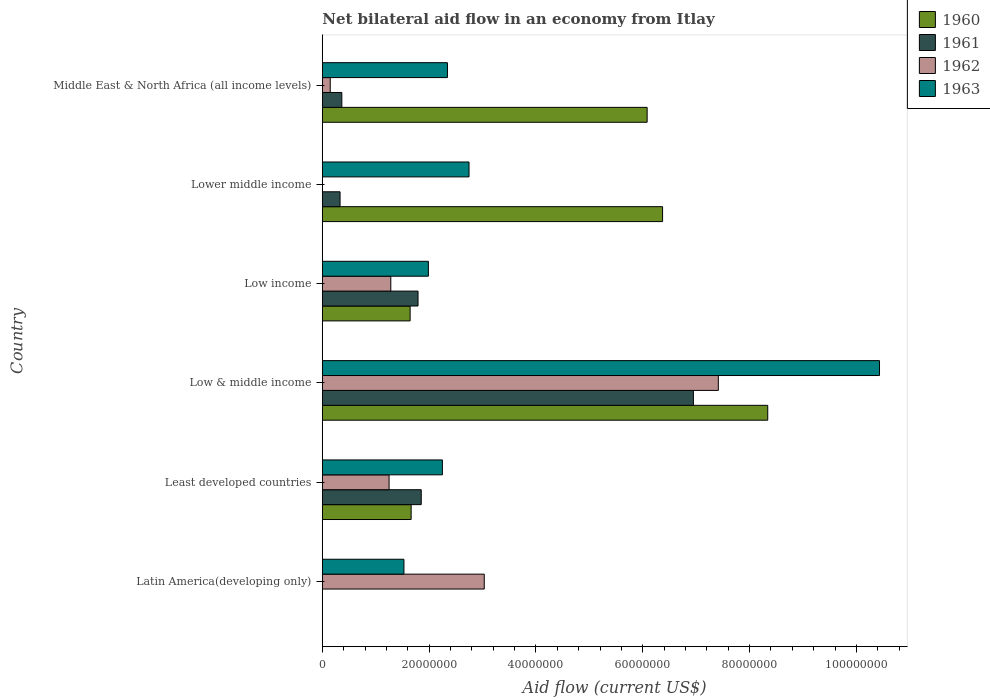How many bars are there on the 2nd tick from the top?
Keep it short and to the point. 3. How many bars are there on the 1st tick from the bottom?
Give a very brief answer. 2. What is the label of the 3rd group of bars from the top?
Offer a very short reply. Low income. What is the net bilateral aid flow in 1963 in Lower middle income?
Provide a succinct answer. 2.75e+07. Across all countries, what is the maximum net bilateral aid flow in 1963?
Provide a succinct answer. 1.04e+08. Across all countries, what is the minimum net bilateral aid flow in 1960?
Offer a terse response. 0. What is the total net bilateral aid flow in 1963 in the graph?
Make the answer very short. 2.13e+08. What is the difference between the net bilateral aid flow in 1963 in Latin America(developing only) and that in Low & middle income?
Give a very brief answer. -8.90e+07. What is the average net bilateral aid flow in 1961 per country?
Keep it short and to the point. 1.88e+07. What is the difference between the net bilateral aid flow in 1962 and net bilateral aid flow in 1961 in Least developed countries?
Offer a very short reply. -6.02e+06. In how many countries, is the net bilateral aid flow in 1960 greater than 104000000 US$?
Offer a terse response. 0. What is the ratio of the net bilateral aid flow in 1961 in Low income to that in Lower middle income?
Make the answer very short. 5.4. Is the net bilateral aid flow in 1963 in Low & middle income less than that in Middle East & North Africa (all income levels)?
Offer a very short reply. No. What is the difference between the highest and the second highest net bilateral aid flow in 1960?
Offer a very short reply. 1.97e+07. What is the difference between the highest and the lowest net bilateral aid flow in 1962?
Ensure brevity in your answer.  7.42e+07. In how many countries, is the net bilateral aid flow in 1962 greater than the average net bilateral aid flow in 1962 taken over all countries?
Your answer should be very brief. 2. Are all the bars in the graph horizontal?
Ensure brevity in your answer.  Yes. Are the values on the major ticks of X-axis written in scientific E-notation?
Provide a short and direct response. No. Does the graph contain any zero values?
Offer a terse response. Yes. How many legend labels are there?
Your answer should be very brief. 4. How are the legend labels stacked?
Give a very brief answer. Vertical. What is the title of the graph?
Ensure brevity in your answer.  Net bilateral aid flow in an economy from Itlay. What is the label or title of the X-axis?
Offer a terse response. Aid flow (current US$). What is the label or title of the Y-axis?
Offer a very short reply. Country. What is the Aid flow (current US$) of 1960 in Latin America(developing only)?
Offer a terse response. 0. What is the Aid flow (current US$) in 1962 in Latin America(developing only)?
Your answer should be compact. 3.03e+07. What is the Aid flow (current US$) in 1963 in Latin America(developing only)?
Your answer should be very brief. 1.53e+07. What is the Aid flow (current US$) in 1960 in Least developed countries?
Ensure brevity in your answer.  1.66e+07. What is the Aid flow (current US$) of 1961 in Least developed countries?
Make the answer very short. 1.85e+07. What is the Aid flow (current US$) in 1962 in Least developed countries?
Your answer should be compact. 1.25e+07. What is the Aid flow (current US$) in 1963 in Least developed countries?
Provide a short and direct response. 2.25e+07. What is the Aid flow (current US$) in 1960 in Low & middle income?
Keep it short and to the point. 8.34e+07. What is the Aid flow (current US$) of 1961 in Low & middle income?
Provide a short and direct response. 6.95e+07. What is the Aid flow (current US$) of 1962 in Low & middle income?
Offer a very short reply. 7.42e+07. What is the Aid flow (current US$) of 1963 in Low & middle income?
Your answer should be compact. 1.04e+08. What is the Aid flow (current US$) in 1960 in Low income?
Ensure brevity in your answer.  1.64e+07. What is the Aid flow (current US$) in 1961 in Low income?
Provide a short and direct response. 1.79e+07. What is the Aid flow (current US$) in 1962 in Low income?
Make the answer very short. 1.28e+07. What is the Aid flow (current US$) in 1963 in Low income?
Offer a very short reply. 1.99e+07. What is the Aid flow (current US$) in 1960 in Lower middle income?
Provide a succinct answer. 6.37e+07. What is the Aid flow (current US$) in 1961 in Lower middle income?
Offer a very short reply. 3.32e+06. What is the Aid flow (current US$) in 1963 in Lower middle income?
Offer a very short reply. 2.75e+07. What is the Aid flow (current US$) in 1960 in Middle East & North Africa (all income levels)?
Offer a very short reply. 6.08e+07. What is the Aid flow (current US$) of 1961 in Middle East & North Africa (all income levels)?
Make the answer very short. 3.65e+06. What is the Aid flow (current US$) in 1962 in Middle East & North Africa (all income levels)?
Give a very brief answer. 1.48e+06. What is the Aid flow (current US$) in 1963 in Middle East & North Africa (all income levels)?
Your answer should be very brief. 2.34e+07. Across all countries, what is the maximum Aid flow (current US$) of 1960?
Provide a short and direct response. 8.34e+07. Across all countries, what is the maximum Aid flow (current US$) of 1961?
Offer a terse response. 6.95e+07. Across all countries, what is the maximum Aid flow (current US$) in 1962?
Offer a very short reply. 7.42e+07. Across all countries, what is the maximum Aid flow (current US$) of 1963?
Make the answer very short. 1.04e+08. Across all countries, what is the minimum Aid flow (current US$) in 1960?
Provide a short and direct response. 0. Across all countries, what is the minimum Aid flow (current US$) of 1961?
Provide a succinct answer. 0. Across all countries, what is the minimum Aid flow (current US$) in 1962?
Offer a terse response. 0. Across all countries, what is the minimum Aid flow (current US$) of 1963?
Offer a terse response. 1.53e+07. What is the total Aid flow (current US$) in 1960 in the graph?
Your answer should be compact. 2.41e+08. What is the total Aid flow (current US$) in 1961 in the graph?
Offer a terse response. 1.13e+08. What is the total Aid flow (current US$) of 1962 in the graph?
Your answer should be very brief. 1.31e+08. What is the total Aid flow (current US$) in 1963 in the graph?
Your response must be concise. 2.13e+08. What is the difference between the Aid flow (current US$) in 1962 in Latin America(developing only) and that in Least developed countries?
Keep it short and to the point. 1.78e+07. What is the difference between the Aid flow (current US$) in 1963 in Latin America(developing only) and that in Least developed countries?
Offer a very short reply. -7.20e+06. What is the difference between the Aid flow (current US$) in 1962 in Latin America(developing only) and that in Low & middle income?
Make the answer very short. -4.38e+07. What is the difference between the Aid flow (current US$) in 1963 in Latin America(developing only) and that in Low & middle income?
Give a very brief answer. -8.90e+07. What is the difference between the Aid flow (current US$) in 1962 in Latin America(developing only) and that in Low income?
Ensure brevity in your answer.  1.75e+07. What is the difference between the Aid flow (current US$) of 1963 in Latin America(developing only) and that in Low income?
Ensure brevity in your answer.  -4.58e+06. What is the difference between the Aid flow (current US$) in 1963 in Latin America(developing only) and that in Lower middle income?
Your response must be concise. -1.22e+07. What is the difference between the Aid flow (current US$) of 1962 in Latin America(developing only) and that in Middle East & North Africa (all income levels)?
Your answer should be compact. 2.88e+07. What is the difference between the Aid flow (current US$) of 1963 in Latin America(developing only) and that in Middle East & North Africa (all income levels)?
Provide a succinct answer. -8.15e+06. What is the difference between the Aid flow (current US$) of 1960 in Least developed countries and that in Low & middle income?
Your answer should be very brief. -6.68e+07. What is the difference between the Aid flow (current US$) in 1961 in Least developed countries and that in Low & middle income?
Provide a short and direct response. -5.10e+07. What is the difference between the Aid flow (current US$) of 1962 in Least developed countries and that in Low & middle income?
Make the answer very short. -6.16e+07. What is the difference between the Aid flow (current US$) of 1963 in Least developed countries and that in Low & middle income?
Keep it short and to the point. -8.18e+07. What is the difference between the Aid flow (current US$) in 1960 in Least developed countries and that in Low income?
Your answer should be very brief. 1.90e+05. What is the difference between the Aid flow (current US$) in 1961 in Least developed countries and that in Low income?
Give a very brief answer. 6.00e+05. What is the difference between the Aid flow (current US$) of 1962 in Least developed countries and that in Low income?
Offer a very short reply. -3.20e+05. What is the difference between the Aid flow (current US$) of 1963 in Least developed countries and that in Low income?
Ensure brevity in your answer.  2.62e+06. What is the difference between the Aid flow (current US$) in 1960 in Least developed countries and that in Lower middle income?
Your response must be concise. -4.71e+07. What is the difference between the Aid flow (current US$) of 1961 in Least developed countries and that in Lower middle income?
Give a very brief answer. 1.52e+07. What is the difference between the Aid flow (current US$) of 1963 in Least developed countries and that in Lower middle income?
Offer a very short reply. -4.99e+06. What is the difference between the Aid flow (current US$) in 1960 in Least developed countries and that in Middle East & North Africa (all income levels)?
Your answer should be very brief. -4.42e+07. What is the difference between the Aid flow (current US$) of 1961 in Least developed countries and that in Middle East & North Africa (all income levels)?
Offer a very short reply. 1.49e+07. What is the difference between the Aid flow (current US$) of 1962 in Least developed countries and that in Middle East & North Africa (all income levels)?
Your answer should be very brief. 1.10e+07. What is the difference between the Aid flow (current US$) of 1963 in Least developed countries and that in Middle East & North Africa (all income levels)?
Ensure brevity in your answer.  -9.50e+05. What is the difference between the Aid flow (current US$) of 1960 in Low & middle income and that in Low income?
Your answer should be very brief. 6.70e+07. What is the difference between the Aid flow (current US$) of 1961 in Low & middle income and that in Low income?
Offer a terse response. 5.16e+07. What is the difference between the Aid flow (current US$) of 1962 in Low & middle income and that in Low income?
Give a very brief answer. 6.13e+07. What is the difference between the Aid flow (current US$) in 1963 in Low & middle income and that in Low income?
Give a very brief answer. 8.45e+07. What is the difference between the Aid flow (current US$) of 1960 in Low & middle income and that in Lower middle income?
Provide a short and direct response. 1.97e+07. What is the difference between the Aid flow (current US$) of 1961 in Low & middle income and that in Lower middle income?
Give a very brief answer. 6.62e+07. What is the difference between the Aid flow (current US$) of 1963 in Low & middle income and that in Lower middle income?
Provide a short and direct response. 7.69e+07. What is the difference between the Aid flow (current US$) of 1960 in Low & middle income and that in Middle East & North Africa (all income levels)?
Your response must be concise. 2.26e+07. What is the difference between the Aid flow (current US$) of 1961 in Low & middle income and that in Middle East & North Africa (all income levels)?
Your answer should be very brief. 6.58e+07. What is the difference between the Aid flow (current US$) of 1962 in Low & middle income and that in Middle East & North Africa (all income levels)?
Offer a very short reply. 7.27e+07. What is the difference between the Aid flow (current US$) of 1963 in Low & middle income and that in Middle East & North Africa (all income levels)?
Provide a succinct answer. 8.09e+07. What is the difference between the Aid flow (current US$) in 1960 in Low income and that in Lower middle income?
Offer a very short reply. -4.73e+07. What is the difference between the Aid flow (current US$) in 1961 in Low income and that in Lower middle income?
Make the answer very short. 1.46e+07. What is the difference between the Aid flow (current US$) in 1963 in Low income and that in Lower middle income?
Give a very brief answer. -7.61e+06. What is the difference between the Aid flow (current US$) in 1960 in Low income and that in Middle East & North Africa (all income levels)?
Make the answer very short. -4.44e+07. What is the difference between the Aid flow (current US$) of 1961 in Low income and that in Middle East & North Africa (all income levels)?
Provide a succinct answer. 1.43e+07. What is the difference between the Aid flow (current US$) in 1962 in Low income and that in Middle East & North Africa (all income levels)?
Keep it short and to the point. 1.13e+07. What is the difference between the Aid flow (current US$) in 1963 in Low income and that in Middle East & North Africa (all income levels)?
Give a very brief answer. -3.57e+06. What is the difference between the Aid flow (current US$) in 1960 in Lower middle income and that in Middle East & North Africa (all income levels)?
Keep it short and to the point. 2.89e+06. What is the difference between the Aid flow (current US$) of 1961 in Lower middle income and that in Middle East & North Africa (all income levels)?
Provide a short and direct response. -3.30e+05. What is the difference between the Aid flow (current US$) of 1963 in Lower middle income and that in Middle East & North Africa (all income levels)?
Ensure brevity in your answer.  4.04e+06. What is the difference between the Aid flow (current US$) in 1962 in Latin America(developing only) and the Aid flow (current US$) in 1963 in Least developed countries?
Your response must be concise. 7.84e+06. What is the difference between the Aid flow (current US$) in 1962 in Latin America(developing only) and the Aid flow (current US$) in 1963 in Low & middle income?
Provide a succinct answer. -7.40e+07. What is the difference between the Aid flow (current US$) of 1962 in Latin America(developing only) and the Aid flow (current US$) of 1963 in Low income?
Give a very brief answer. 1.05e+07. What is the difference between the Aid flow (current US$) of 1962 in Latin America(developing only) and the Aid flow (current US$) of 1963 in Lower middle income?
Ensure brevity in your answer.  2.85e+06. What is the difference between the Aid flow (current US$) in 1962 in Latin America(developing only) and the Aid flow (current US$) in 1963 in Middle East & North Africa (all income levels)?
Your answer should be compact. 6.89e+06. What is the difference between the Aid flow (current US$) in 1960 in Least developed countries and the Aid flow (current US$) in 1961 in Low & middle income?
Your response must be concise. -5.28e+07. What is the difference between the Aid flow (current US$) in 1960 in Least developed countries and the Aid flow (current US$) in 1962 in Low & middle income?
Provide a succinct answer. -5.75e+07. What is the difference between the Aid flow (current US$) of 1960 in Least developed countries and the Aid flow (current US$) of 1963 in Low & middle income?
Your response must be concise. -8.77e+07. What is the difference between the Aid flow (current US$) in 1961 in Least developed countries and the Aid flow (current US$) in 1962 in Low & middle income?
Give a very brief answer. -5.56e+07. What is the difference between the Aid flow (current US$) in 1961 in Least developed countries and the Aid flow (current US$) in 1963 in Low & middle income?
Provide a succinct answer. -8.58e+07. What is the difference between the Aid flow (current US$) in 1962 in Least developed countries and the Aid flow (current US$) in 1963 in Low & middle income?
Your answer should be very brief. -9.18e+07. What is the difference between the Aid flow (current US$) of 1960 in Least developed countries and the Aid flow (current US$) of 1961 in Low income?
Keep it short and to the point. -1.29e+06. What is the difference between the Aid flow (current US$) of 1960 in Least developed countries and the Aid flow (current US$) of 1962 in Low income?
Offer a terse response. 3.81e+06. What is the difference between the Aid flow (current US$) in 1960 in Least developed countries and the Aid flow (current US$) in 1963 in Low income?
Provide a short and direct response. -3.23e+06. What is the difference between the Aid flow (current US$) in 1961 in Least developed countries and the Aid flow (current US$) in 1962 in Low income?
Ensure brevity in your answer.  5.70e+06. What is the difference between the Aid flow (current US$) in 1961 in Least developed countries and the Aid flow (current US$) in 1963 in Low income?
Keep it short and to the point. -1.34e+06. What is the difference between the Aid flow (current US$) of 1962 in Least developed countries and the Aid flow (current US$) of 1963 in Low income?
Keep it short and to the point. -7.36e+06. What is the difference between the Aid flow (current US$) in 1960 in Least developed countries and the Aid flow (current US$) in 1961 in Lower middle income?
Offer a very short reply. 1.33e+07. What is the difference between the Aid flow (current US$) in 1960 in Least developed countries and the Aid flow (current US$) in 1963 in Lower middle income?
Provide a short and direct response. -1.08e+07. What is the difference between the Aid flow (current US$) in 1961 in Least developed countries and the Aid flow (current US$) in 1963 in Lower middle income?
Offer a very short reply. -8.95e+06. What is the difference between the Aid flow (current US$) of 1962 in Least developed countries and the Aid flow (current US$) of 1963 in Lower middle income?
Your answer should be very brief. -1.50e+07. What is the difference between the Aid flow (current US$) in 1960 in Least developed countries and the Aid flow (current US$) in 1961 in Middle East & North Africa (all income levels)?
Make the answer very short. 1.30e+07. What is the difference between the Aid flow (current US$) in 1960 in Least developed countries and the Aid flow (current US$) in 1962 in Middle East & North Africa (all income levels)?
Offer a terse response. 1.52e+07. What is the difference between the Aid flow (current US$) in 1960 in Least developed countries and the Aid flow (current US$) in 1963 in Middle East & North Africa (all income levels)?
Your answer should be very brief. -6.80e+06. What is the difference between the Aid flow (current US$) of 1961 in Least developed countries and the Aid flow (current US$) of 1962 in Middle East & North Africa (all income levels)?
Your response must be concise. 1.70e+07. What is the difference between the Aid flow (current US$) of 1961 in Least developed countries and the Aid flow (current US$) of 1963 in Middle East & North Africa (all income levels)?
Provide a short and direct response. -4.91e+06. What is the difference between the Aid flow (current US$) in 1962 in Least developed countries and the Aid flow (current US$) in 1963 in Middle East & North Africa (all income levels)?
Your answer should be compact. -1.09e+07. What is the difference between the Aid flow (current US$) in 1960 in Low & middle income and the Aid flow (current US$) in 1961 in Low income?
Provide a succinct answer. 6.55e+07. What is the difference between the Aid flow (current US$) of 1960 in Low & middle income and the Aid flow (current US$) of 1962 in Low income?
Your answer should be compact. 7.06e+07. What is the difference between the Aid flow (current US$) of 1960 in Low & middle income and the Aid flow (current US$) of 1963 in Low income?
Give a very brief answer. 6.35e+07. What is the difference between the Aid flow (current US$) of 1961 in Low & middle income and the Aid flow (current US$) of 1962 in Low income?
Keep it short and to the point. 5.67e+07. What is the difference between the Aid flow (current US$) in 1961 in Low & middle income and the Aid flow (current US$) in 1963 in Low income?
Provide a succinct answer. 4.96e+07. What is the difference between the Aid flow (current US$) in 1962 in Low & middle income and the Aid flow (current US$) in 1963 in Low income?
Offer a very short reply. 5.43e+07. What is the difference between the Aid flow (current US$) of 1960 in Low & middle income and the Aid flow (current US$) of 1961 in Lower middle income?
Offer a very short reply. 8.01e+07. What is the difference between the Aid flow (current US$) of 1960 in Low & middle income and the Aid flow (current US$) of 1963 in Lower middle income?
Make the answer very short. 5.59e+07. What is the difference between the Aid flow (current US$) of 1961 in Low & middle income and the Aid flow (current US$) of 1963 in Lower middle income?
Make the answer very short. 4.20e+07. What is the difference between the Aid flow (current US$) of 1962 in Low & middle income and the Aid flow (current US$) of 1963 in Lower middle income?
Your answer should be very brief. 4.67e+07. What is the difference between the Aid flow (current US$) of 1960 in Low & middle income and the Aid flow (current US$) of 1961 in Middle East & North Africa (all income levels)?
Offer a terse response. 7.98e+07. What is the difference between the Aid flow (current US$) in 1960 in Low & middle income and the Aid flow (current US$) in 1962 in Middle East & North Africa (all income levels)?
Your answer should be compact. 8.19e+07. What is the difference between the Aid flow (current US$) of 1960 in Low & middle income and the Aid flow (current US$) of 1963 in Middle East & North Africa (all income levels)?
Give a very brief answer. 6.00e+07. What is the difference between the Aid flow (current US$) of 1961 in Low & middle income and the Aid flow (current US$) of 1962 in Middle East & North Africa (all income levels)?
Provide a succinct answer. 6.80e+07. What is the difference between the Aid flow (current US$) of 1961 in Low & middle income and the Aid flow (current US$) of 1963 in Middle East & North Africa (all income levels)?
Keep it short and to the point. 4.60e+07. What is the difference between the Aid flow (current US$) in 1962 in Low & middle income and the Aid flow (current US$) in 1963 in Middle East & North Africa (all income levels)?
Your answer should be compact. 5.07e+07. What is the difference between the Aid flow (current US$) of 1960 in Low income and the Aid flow (current US$) of 1961 in Lower middle income?
Ensure brevity in your answer.  1.31e+07. What is the difference between the Aid flow (current US$) in 1960 in Low income and the Aid flow (current US$) in 1963 in Lower middle income?
Ensure brevity in your answer.  -1.10e+07. What is the difference between the Aid flow (current US$) of 1961 in Low income and the Aid flow (current US$) of 1963 in Lower middle income?
Make the answer very short. -9.55e+06. What is the difference between the Aid flow (current US$) in 1962 in Low income and the Aid flow (current US$) in 1963 in Lower middle income?
Give a very brief answer. -1.46e+07. What is the difference between the Aid flow (current US$) of 1960 in Low income and the Aid flow (current US$) of 1961 in Middle East & North Africa (all income levels)?
Provide a succinct answer. 1.28e+07. What is the difference between the Aid flow (current US$) of 1960 in Low income and the Aid flow (current US$) of 1962 in Middle East & North Africa (all income levels)?
Your answer should be compact. 1.50e+07. What is the difference between the Aid flow (current US$) of 1960 in Low income and the Aid flow (current US$) of 1963 in Middle East & North Africa (all income levels)?
Your answer should be compact. -6.99e+06. What is the difference between the Aid flow (current US$) in 1961 in Low income and the Aid flow (current US$) in 1962 in Middle East & North Africa (all income levels)?
Provide a short and direct response. 1.64e+07. What is the difference between the Aid flow (current US$) in 1961 in Low income and the Aid flow (current US$) in 1963 in Middle East & North Africa (all income levels)?
Provide a short and direct response. -5.51e+06. What is the difference between the Aid flow (current US$) in 1962 in Low income and the Aid flow (current US$) in 1963 in Middle East & North Africa (all income levels)?
Ensure brevity in your answer.  -1.06e+07. What is the difference between the Aid flow (current US$) of 1960 in Lower middle income and the Aid flow (current US$) of 1961 in Middle East & North Africa (all income levels)?
Provide a succinct answer. 6.01e+07. What is the difference between the Aid flow (current US$) in 1960 in Lower middle income and the Aid flow (current US$) in 1962 in Middle East & North Africa (all income levels)?
Ensure brevity in your answer.  6.22e+07. What is the difference between the Aid flow (current US$) of 1960 in Lower middle income and the Aid flow (current US$) of 1963 in Middle East & North Africa (all income levels)?
Provide a short and direct response. 4.03e+07. What is the difference between the Aid flow (current US$) of 1961 in Lower middle income and the Aid flow (current US$) of 1962 in Middle East & North Africa (all income levels)?
Provide a short and direct response. 1.84e+06. What is the difference between the Aid flow (current US$) in 1961 in Lower middle income and the Aid flow (current US$) in 1963 in Middle East & North Africa (all income levels)?
Your answer should be very brief. -2.01e+07. What is the average Aid flow (current US$) in 1960 per country?
Give a very brief answer. 4.02e+07. What is the average Aid flow (current US$) in 1961 per country?
Offer a terse response. 1.88e+07. What is the average Aid flow (current US$) in 1962 per country?
Your response must be concise. 2.19e+07. What is the average Aid flow (current US$) of 1963 per country?
Offer a very short reply. 3.55e+07. What is the difference between the Aid flow (current US$) of 1962 and Aid flow (current US$) of 1963 in Latin America(developing only)?
Make the answer very short. 1.50e+07. What is the difference between the Aid flow (current US$) of 1960 and Aid flow (current US$) of 1961 in Least developed countries?
Make the answer very short. -1.89e+06. What is the difference between the Aid flow (current US$) of 1960 and Aid flow (current US$) of 1962 in Least developed countries?
Offer a very short reply. 4.13e+06. What is the difference between the Aid flow (current US$) of 1960 and Aid flow (current US$) of 1963 in Least developed countries?
Your response must be concise. -5.85e+06. What is the difference between the Aid flow (current US$) in 1961 and Aid flow (current US$) in 1962 in Least developed countries?
Your answer should be very brief. 6.02e+06. What is the difference between the Aid flow (current US$) in 1961 and Aid flow (current US$) in 1963 in Least developed countries?
Your response must be concise. -3.96e+06. What is the difference between the Aid flow (current US$) in 1962 and Aid flow (current US$) in 1963 in Least developed countries?
Your answer should be compact. -9.98e+06. What is the difference between the Aid flow (current US$) of 1960 and Aid flow (current US$) of 1961 in Low & middle income?
Keep it short and to the point. 1.39e+07. What is the difference between the Aid flow (current US$) in 1960 and Aid flow (current US$) in 1962 in Low & middle income?
Provide a succinct answer. 9.25e+06. What is the difference between the Aid flow (current US$) in 1960 and Aid flow (current US$) in 1963 in Low & middle income?
Offer a very short reply. -2.09e+07. What is the difference between the Aid flow (current US$) of 1961 and Aid flow (current US$) of 1962 in Low & middle income?
Give a very brief answer. -4.67e+06. What is the difference between the Aid flow (current US$) of 1961 and Aid flow (current US$) of 1963 in Low & middle income?
Make the answer very short. -3.48e+07. What is the difference between the Aid flow (current US$) in 1962 and Aid flow (current US$) in 1963 in Low & middle income?
Your response must be concise. -3.02e+07. What is the difference between the Aid flow (current US$) in 1960 and Aid flow (current US$) in 1961 in Low income?
Make the answer very short. -1.48e+06. What is the difference between the Aid flow (current US$) of 1960 and Aid flow (current US$) of 1962 in Low income?
Offer a very short reply. 3.62e+06. What is the difference between the Aid flow (current US$) of 1960 and Aid flow (current US$) of 1963 in Low income?
Keep it short and to the point. -3.42e+06. What is the difference between the Aid flow (current US$) of 1961 and Aid flow (current US$) of 1962 in Low income?
Your answer should be compact. 5.10e+06. What is the difference between the Aid flow (current US$) in 1961 and Aid flow (current US$) in 1963 in Low income?
Offer a terse response. -1.94e+06. What is the difference between the Aid flow (current US$) of 1962 and Aid flow (current US$) of 1963 in Low income?
Your response must be concise. -7.04e+06. What is the difference between the Aid flow (current US$) of 1960 and Aid flow (current US$) of 1961 in Lower middle income?
Your response must be concise. 6.04e+07. What is the difference between the Aid flow (current US$) in 1960 and Aid flow (current US$) in 1963 in Lower middle income?
Offer a terse response. 3.62e+07. What is the difference between the Aid flow (current US$) of 1961 and Aid flow (current US$) of 1963 in Lower middle income?
Offer a terse response. -2.42e+07. What is the difference between the Aid flow (current US$) in 1960 and Aid flow (current US$) in 1961 in Middle East & North Africa (all income levels)?
Your answer should be very brief. 5.72e+07. What is the difference between the Aid flow (current US$) in 1960 and Aid flow (current US$) in 1962 in Middle East & North Africa (all income levels)?
Keep it short and to the point. 5.93e+07. What is the difference between the Aid flow (current US$) in 1960 and Aid flow (current US$) in 1963 in Middle East & North Africa (all income levels)?
Your answer should be compact. 3.74e+07. What is the difference between the Aid flow (current US$) of 1961 and Aid flow (current US$) of 1962 in Middle East & North Africa (all income levels)?
Offer a very short reply. 2.17e+06. What is the difference between the Aid flow (current US$) in 1961 and Aid flow (current US$) in 1963 in Middle East & North Africa (all income levels)?
Provide a succinct answer. -1.98e+07. What is the difference between the Aid flow (current US$) in 1962 and Aid flow (current US$) in 1963 in Middle East & North Africa (all income levels)?
Ensure brevity in your answer.  -2.20e+07. What is the ratio of the Aid flow (current US$) in 1962 in Latin America(developing only) to that in Least developed countries?
Offer a terse response. 2.43. What is the ratio of the Aid flow (current US$) of 1963 in Latin America(developing only) to that in Least developed countries?
Give a very brief answer. 0.68. What is the ratio of the Aid flow (current US$) in 1962 in Latin America(developing only) to that in Low & middle income?
Your answer should be very brief. 0.41. What is the ratio of the Aid flow (current US$) of 1963 in Latin America(developing only) to that in Low & middle income?
Offer a very short reply. 0.15. What is the ratio of the Aid flow (current US$) in 1962 in Latin America(developing only) to that in Low income?
Provide a succinct answer. 2.37. What is the ratio of the Aid flow (current US$) of 1963 in Latin America(developing only) to that in Low income?
Give a very brief answer. 0.77. What is the ratio of the Aid flow (current US$) in 1963 in Latin America(developing only) to that in Lower middle income?
Your response must be concise. 0.56. What is the ratio of the Aid flow (current US$) in 1962 in Latin America(developing only) to that in Middle East & North Africa (all income levels)?
Provide a short and direct response. 20.49. What is the ratio of the Aid flow (current US$) of 1963 in Latin America(developing only) to that in Middle East & North Africa (all income levels)?
Ensure brevity in your answer.  0.65. What is the ratio of the Aid flow (current US$) in 1960 in Least developed countries to that in Low & middle income?
Offer a terse response. 0.2. What is the ratio of the Aid flow (current US$) in 1961 in Least developed countries to that in Low & middle income?
Your answer should be very brief. 0.27. What is the ratio of the Aid flow (current US$) in 1962 in Least developed countries to that in Low & middle income?
Offer a terse response. 0.17. What is the ratio of the Aid flow (current US$) in 1963 in Least developed countries to that in Low & middle income?
Your answer should be very brief. 0.22. What is the ratio of the Aid flow (current US$) of 1960 in Least developed countries to that in Low income?
Provide a short and direct response. 1.01. What is the ratio of the Aid flow (current US$) of 1961 in Least developed countries to that in Low income?
Your answer should be very brief. 1.03. What is the ratio of the Aid flow (current US$) in 1963 in Least developed countries to that in Low income?
Keep it short and to the point. 1.13. What is the ratio of the Aid flow (current US$) in 1960 in Least developed countries to that in Lower middle income?
Provide a short and direct response. 0.26. What is the ratio of the Aid flow (current US$) in 1961 in Least developed countries to that in Lower middle income?
Your answer should be very brief. 5.58. What is the ratio of the Aid flow (current US$) of 1963 in Least developed countries to that in Lower middle income?
Your answer should be compact. 0.82. What is the ratio of the Aid flow (current US$) in 1960 in Least developed countries to that in Middle East & North Africa (all income levels)?
Ensure brevity in your answer.  0.27. What is the ratio of the Aid flow (current US$) in 1961 in Least developed countries to that in Middle East & North Africa (all income levels)?
Provide a succinct answer. 5.07. What is the ratio of the Aid flow (current US$) in 1962 in Least developed countries to that in Middle East & North Africa (all income levels)?
Your response must be concise. 8.45. What is the ratio of the Aid flow (current US$) of 1963 in Least developed countries to that in Middle East & North Africa (all income levels)?
Your answer should be compact. 0.96. What is the ratio of the Aid flow (current US$) in 1960 in Low & middle income to that in Low income?
Your response must be concise. 5.07. What is the ratio of the Aid flow (current US$) in 1961 in Low & middle income to that in Low income?
Make the answer very short. 3.88. What is the ratio of the Aid flow (current US$) in 1962 in Low & middle income to that in Low income?
Offer a very short reply. 5.78. What is the ratio of the Aid flow (current US$) in 1963 in Low & middle income to that in Low income?
Ensure brevity in your answer.  5.25. What is the ratio of the Aid flow (current US$) of 1960 in Low & middle income to that in Lower middle income?
Provide a succinct answer. 1.31. What is the ratio of the Aid flow (current US$) in 1961 in Low & middle income to that in Lower middle income?
Keep it short and to the point. 20.93. What is the ratio of the Aid flow (current US$) in 1963 in Low & middle income to that in Lower middle income?
Offer a very short reply. 3.8. What is the ratio of the Aid flow (current US$) of 1960 in Low & middle income to that in Middle East & North Africa (all income levels)?
Your answer should be very brief. 1.37. What is the ratio of the Aid flow (current US$) of 1961 in Low & middle income to that in Middle East & North Africa (all income levels)?
Make the answer very short. 19.04. What is the ratio of the Aid flow (current US$) in 1962 in Low & middle income to that in Middle East & North Africa (all income levels)?
Provide a succinct answer. 50.1. What is the ratio of the Aid flow (current US$) of 1963 in Low & middle income to that in Middle East & North Africa (all income levels)?
Your answer should be compact. 4.45. What is the ratio of the Aid flow (current US$) in 1960 in Low income to that in Lower middle income?
Your answer should be compact. 0.26. What is the ratio of the Aid flow (current US$) in 1961 in Low income to that in Lower middle income?
Offer a terse response. 5.4. What is the ratio of the Aid flow (current US$) of 1963 in Low income to that in Lower middle income?
Provide a short and direct response. 0.72. What is the ratio of the Aid flow (current US$) in 1960 in Low income to that in Middle East & North Africa (all income levels)?
Make the answer very short. 0.27. What is the ratio of the Aid flow (current US$) in 1961 in Low income to that in Middle East & North Africa (all income levels)?
Ensure brevity in your answer.  4.91. What is the ratio of the Aid flow (current US$) in 1962 in Low income to that in Middle East & North Africa (all income levels)?
Your answer should be very brief. 8.66. What is the ratio of the Aid flow (current US$) of 1963 in Low income to that in Middle East & North Africa (all income levels)?
Provide a succinct answer. 0.85. What is the ratio of the Aid flow (current US$) of 1960 in Lower middle income to that in Middle East & North Africa (all income levels)?
Your response must be concise. 1.05. What is the ratio of the Aid flow (current US$) of 1961 in Lower middle income to that in Middle East & North Africa (all income levels)?
Offer a very short reply. 0.91. What is the ratio of the Aid flow (current US$) in 1963 in Lower middle income to that in Middle East & North Africa (all income levels)?
Offer a terse response. 1.17. What is the difference between the highest and the second highest Aid flow (current US$) of 1960?
Ensure brevity in your answer.  1.97e+07. What is the difference between the highest and the second highest Aid flow (current US$) in 1961?
Your response must be concise. 5.10e+07. What is the difference between the highest and the second highest Aid flow (current US$) of 1962?
Make the answer very short. 4.38e+07. What is the difference between the highest and the second highest Aid flow (current US$) in 1963?
Provide a short and direct response. 7.69e+07. What is the difference between the highest and the lowest Aid flow (current US$) in 1960?
Your answer should be compact. 8.34e+07. What is the difference between the highest and the lowest Aid flow (current US$) of 1961?
Your answer should be compact. 6.95e+07. What is the difference between the highest and the lowest Aid flow (current US$) in 1962?
Give a very brief answer. 7.42e+07. What is the difference between the highest and the lowest Aid flow (current US$) in 1963?
Give a very brief answer. 8.90e+07. 